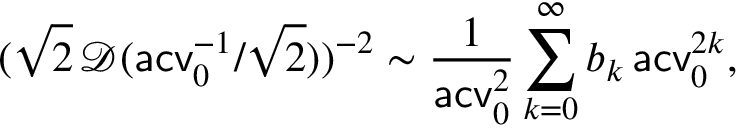<formula> <loc_0><loc_0><loc_500><loc_500>( \sqrt { 2 } \, \mathcal { D } ( a c v _ { 0 } ^ { - 1 } / \sqrt { 2 } ) ) ^ { - 2 } \sim \frac { 1 } { a c v _ { 0 } ^ { 2 } } \sum _ { k = 0 } ^ { \infty } b _ { k } \, a c v _ { 0 } ^ { 2 k } ,</formula> 